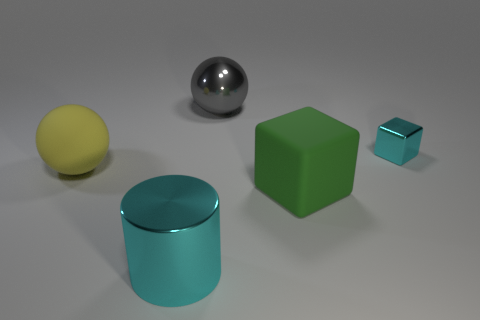Is the metal cube the same color as the big cube?
Offer a terse response. No. Is there anything else that has the same shape as the large yellow matte thing?
Offer a very short reply. Yes. Is there another metallic cylinder that has the same color as the big metallic cylinder?
Your answer should be very brief. No. Is the material of the cyan object that is on the right side of the large green rubber thing the same as the large yellow ball that is in front of the large gray ball?
Offer a very short reply. No. What is the color of the big shiny cylinder?
Offer a very short reply. Cyan. How big is the cyan thing that is left of the cube that is in front of the matte object to the left of the large gray shiny thing?
Your response must be concise. Large. How many other objects are the same size as the cyan metal cylinder?
Your answer should be compact. 3. How many big cyan cylinders have the same material as the gray sphere?
Make the answer very short. 1. The large shiny thing that is right of the big cyan thing has what shape?
Make the answer very short. Sphere. Is the cylinder made of the same material as the large sphere that is in front of the metallic ball?
Give a very brief answer. No. 